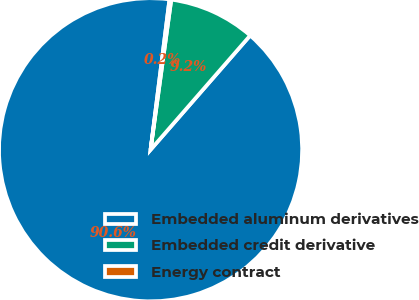<chart> <loc_0><loc_0><loc_500><loc_500><pie_chart><fcel>Embedded aluminum derivatives<fcel>Embedded credit derivative<fcel>Energy contract<nl><fcel>90.59%<fcel>9.23%<fcel>0.19%<nl></chart> 